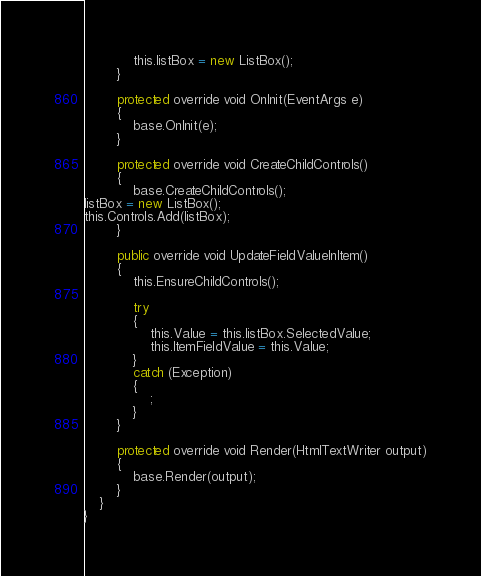<code> <loc_0><loc_0><loc_500><loc_500><_VisualBasic_>            this.listBox = new ListBox();
        }

        protected override void OnInit(EventArgs e)
        {
            base.OnInit(e);
        }

        protected override void CreateChildControls()
        {
            base.CreateChildControls(); 
listBox = new ListBox();
this.Controls.Add(listBox);
        }

        public override void UpdateFieldValueInItem()
        {
            this.EnsureChildControls();

            try
            {
                this.Value = this.listBox.SelectedValue;
                this.ItemFieldValue = this.Value;
            }
            catch (Exception)
            {
                ;
            }
        }

        protected override void Render(HtmlTextWriter output)
        {
            base.Render(output);
        }
    }
}

</code> 